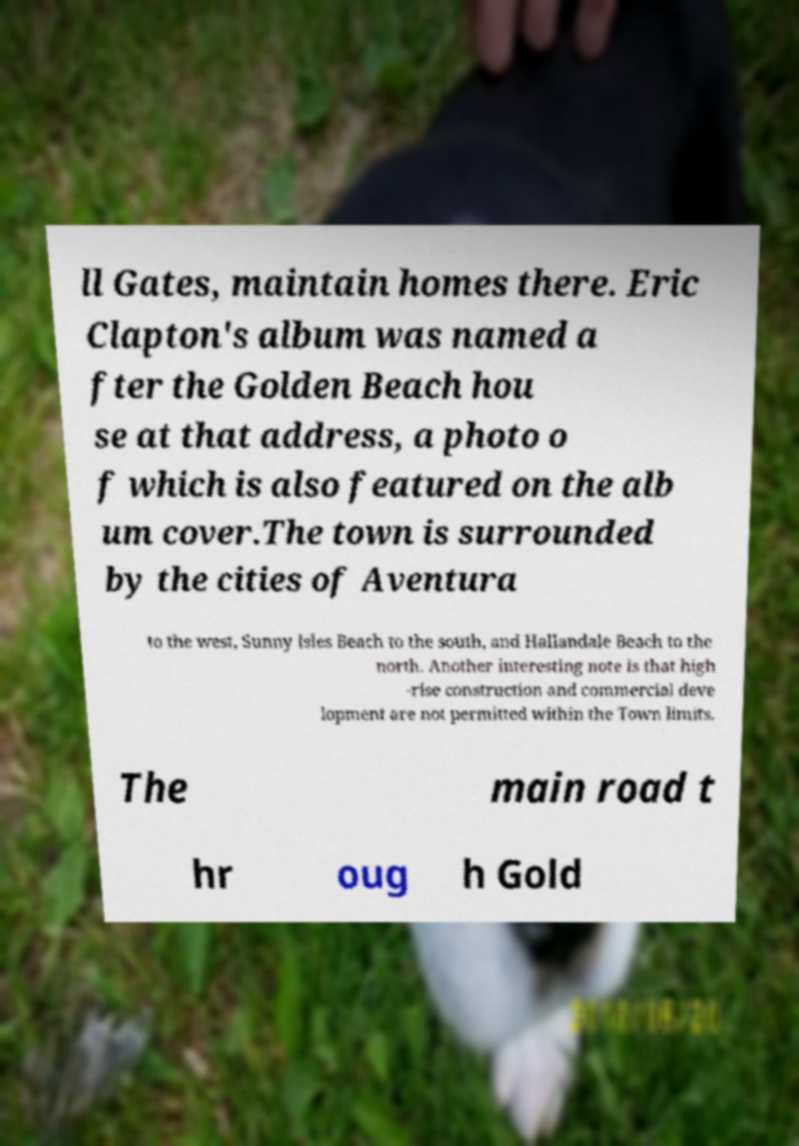Could you assist in decoding the text presented in this image and type it out clearly? ll Gates, maintain homes there. Eric Clapton's album was named a fter the Golden Beach hou se at that address, a photo o f which is also featured on the alb um cover.The town is surrounded by the cities of Aventura to the west, Sunny Isles Beach to the south, and Hallandale Beach to the north. Another interesting note is that high -rise construction and commercial deve lopment are not permitted within the Town limits. The main road t hr oug h Gold 